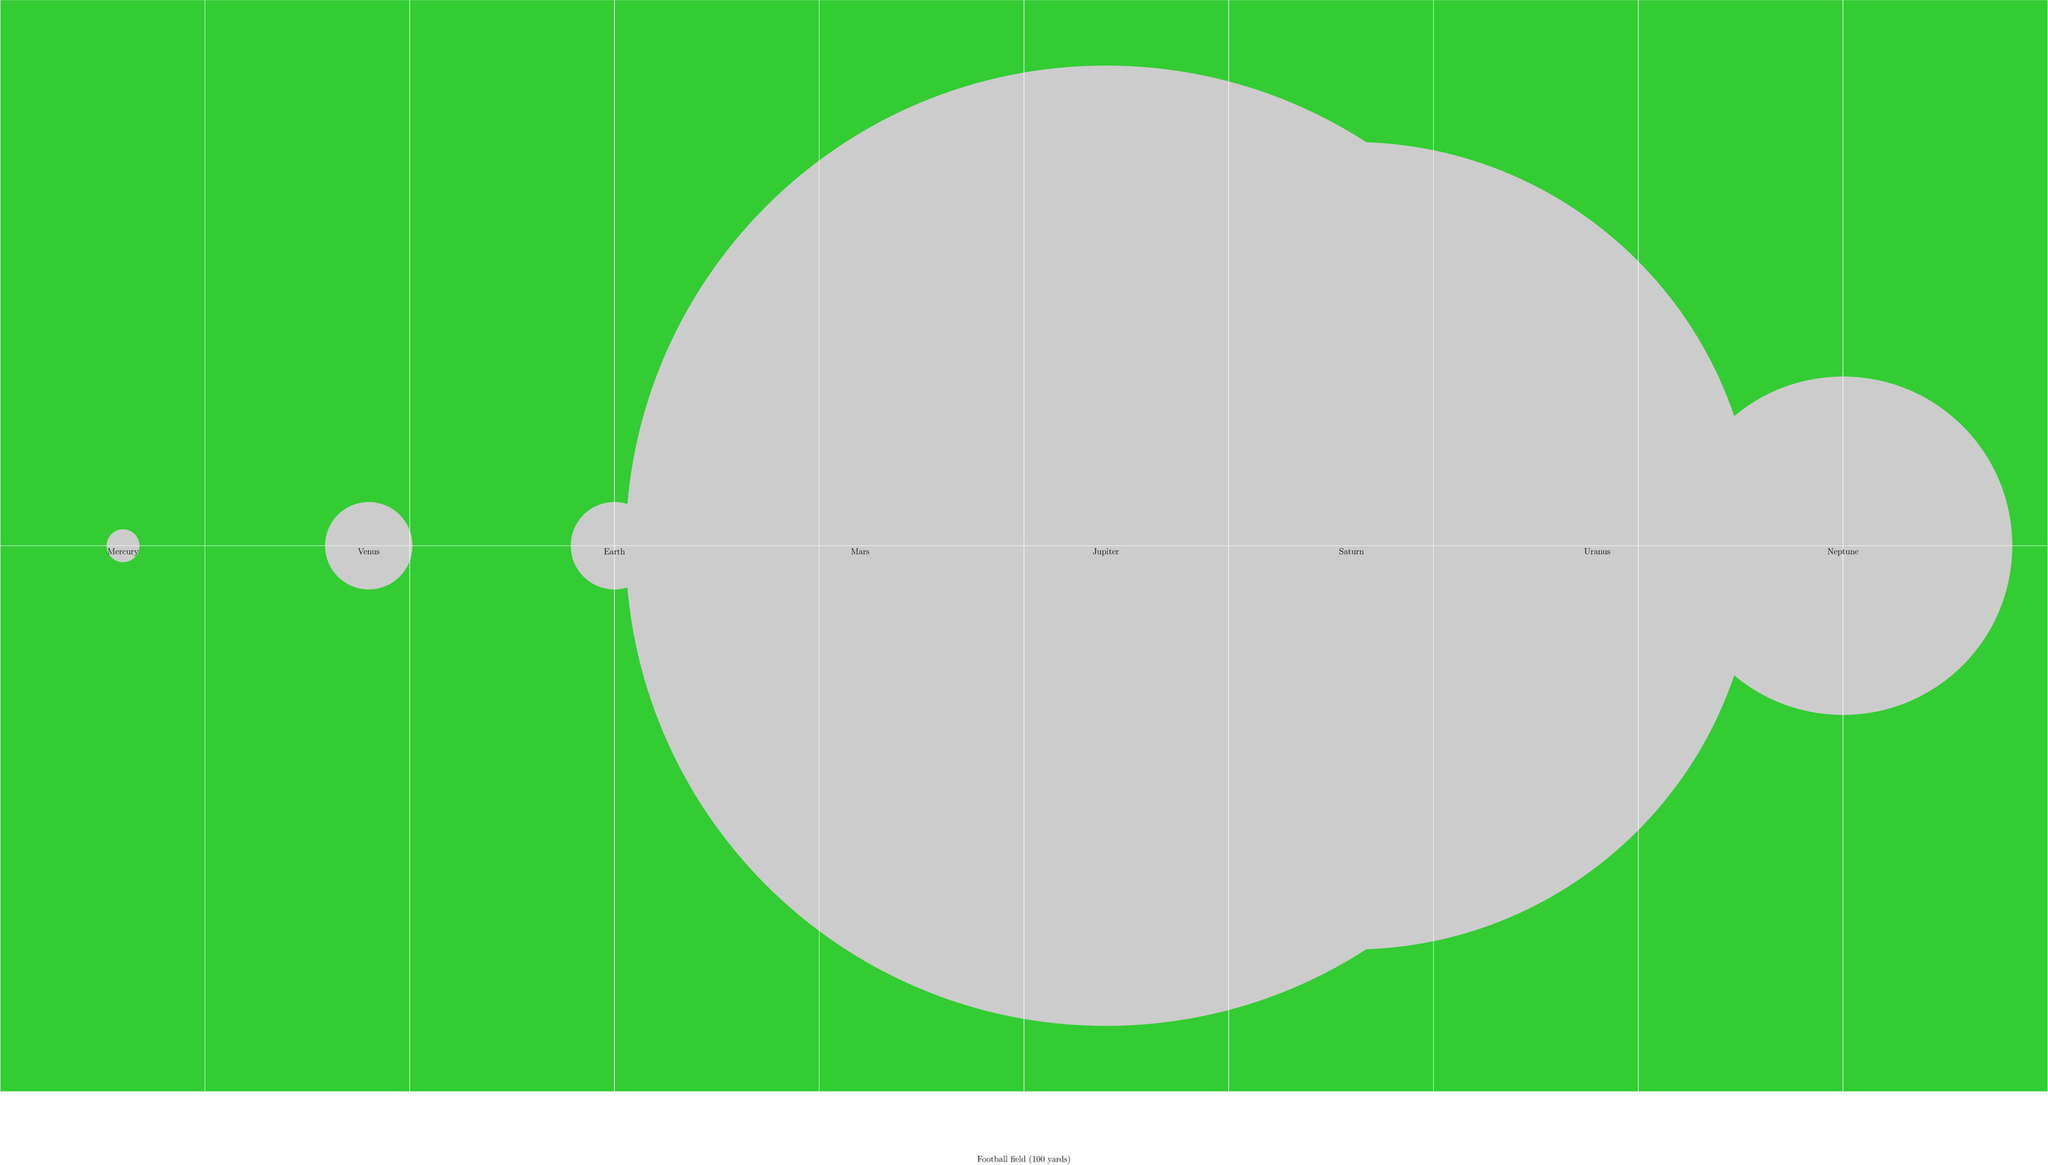If a football field represents the diameter of Jupiter, which planet would be closest in size to the width of the goal line (which is 8 inches or about 20 cm wide)? To solve this problem, let's follow these steps:

1) First, we need to understand the scale. The diagram shows that Jupiter's diameter is represented by the length of a football field (100 yards or 91.44 meters).

2) Jupiter's actual diameter is about 139,820 km. So our scale is:
   $\frac{91.44 \text{ m}}{139,820,000 \text{ m}} = \frac{1}{1,529,308}$

3) The width of a goal line is 8 inches (20.32 cm). At our scale, this represents:
   $20.32 \text{ cm} \times 1,529,308 = 31,075 \text{ km}$

4) Now, let's compare this to the diameters of the planets:
   - Mercury: 4,879 km
   - Venus: 12,104 km
   - Earth: 12,742 km
   - Mars: 6,779 km
   - Jupiter: 139,820 km (our reference)
   - Saturn: 116,460 km
   - Uranus: 50,724 km
   - Neptune: 49,244 km

5) The planet closest to 31,075 km in diameter is Uranus at 50,724 km.
Answer: Uranus 